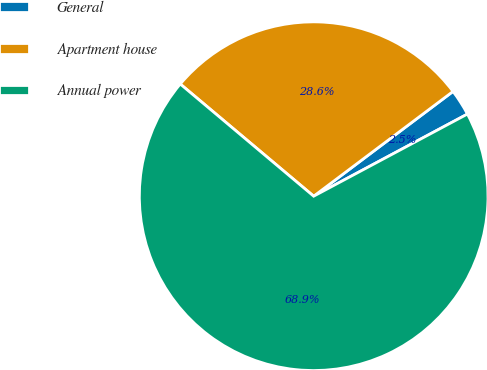<chart> <loc_0><loc_0><loc_500><loc_500><pie_chart><fcel>General<fcel>Apartment house<fcel>Annual power<nl><fcel>2.45%<fcel>28.61%<fcel>68.93%<nl></chart> 